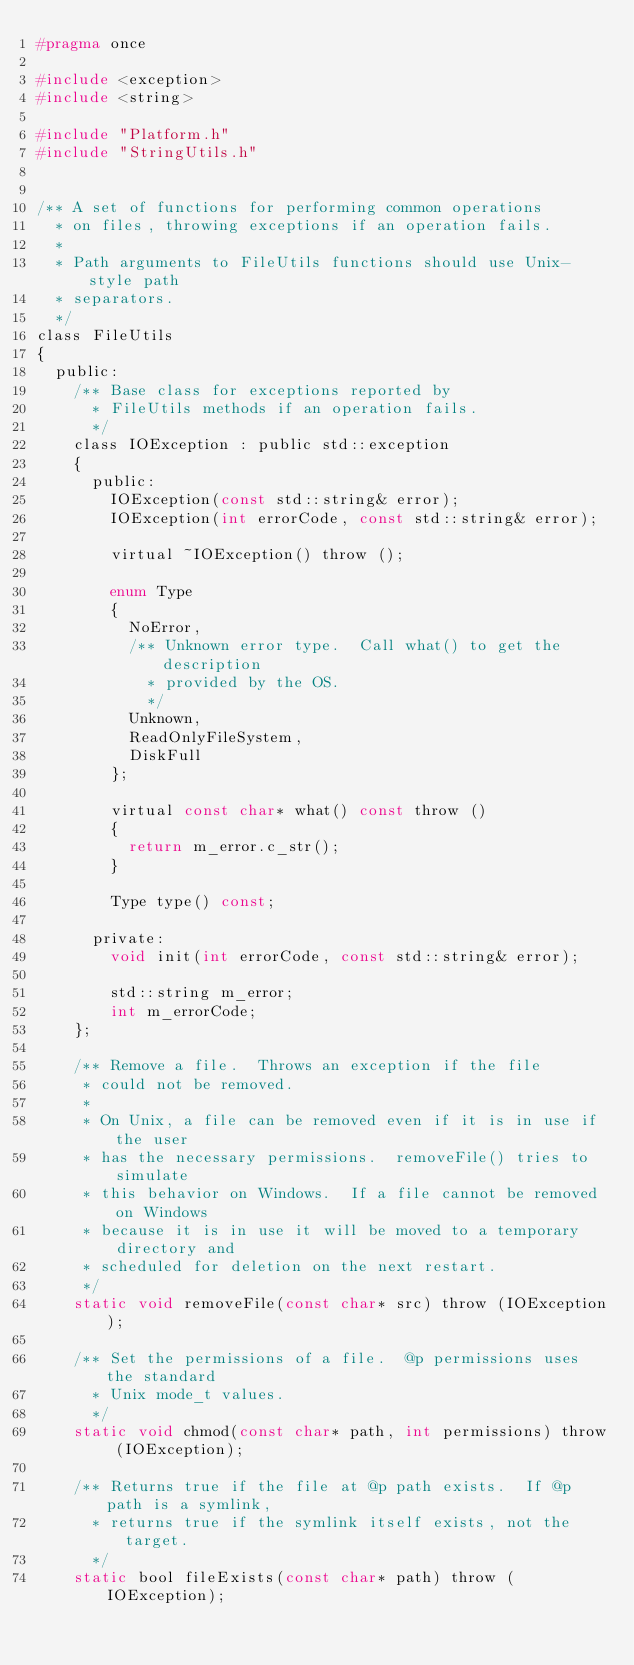Convert code to text. <code><loc_0><loc_0><loc_500><loc_500><_C_>#pragma once

#include <exception>
#include <string>

#include "Platform.h"
#include "StringUtils.h"


/** A set of functions for performing common operations
  * on files, throwing exceptions if an operation fails.
  *
  * Path arguments to FileUtils functions should use Unix-style path
  * separators.
  */
class FileUtils
{
	public:
		/** Base class for exceptions reported by
		  * FileUtils methods if an operation fails.
		  */
		class IOException : public std::exception
		{
			public:
				IOException(const std::string& error);
				IOException(int errorCode, const std::string& error);

				virtual ~IOException() throw ();

				enum Type
				{
					NoError,
					/** Unknown error type.  Call what() to get the description
					  * provided by the OS.
					  */
					Unknown,
					ReadOnlyFileSystem,
					DiskFull
				};

				virtual const char* what() const throw ()
				{
					return m_error.c_str();
				}

				Type type() const;

			private:
				void init(int errorCode, const std::string& error);

				std::string m_error;
				int m_errorCode;
		};

		/** Remove a file.  Throws an exception if the file
		 * could not be removed.
		 *
		 * On Unix, a file can be removed even if it is in use if the user
		 * has the necessary permissions.  removeFile() tries to simulate
		 * this behavior on Windows.  If a file cannot be removed on Windows
		 * because it is in use it will be moved to a temporary directory and
		 * scheduled for deletion on the next restart.
		 */
		static void removeFile(const char* src) throw (IOException);

		/** Set the permissions of a file.  @p permissions uses the standard
		  * Unix mode_t values.
		  */
		static void chmod(const char* path, int permissions) throw (IOException);

		/** Returns true if the file at @p path exists.  If @p path is a symlink,
		  * returns true if the symlink itself exists, not the target.
		  */
		static bool fileExists(const char* path) throw (IOException);
</code> 